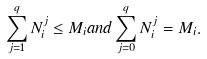<formula> <loc_0><loc_0><loc_500><loc_500>\sum _ { j = 1 } ^ { q } N _ { i } ^ { j } \leq M _ { i } a n d \sum _ { j = 0 } ^ { q } N _ { i } ^ { j } = M _ { i } .</formula> 